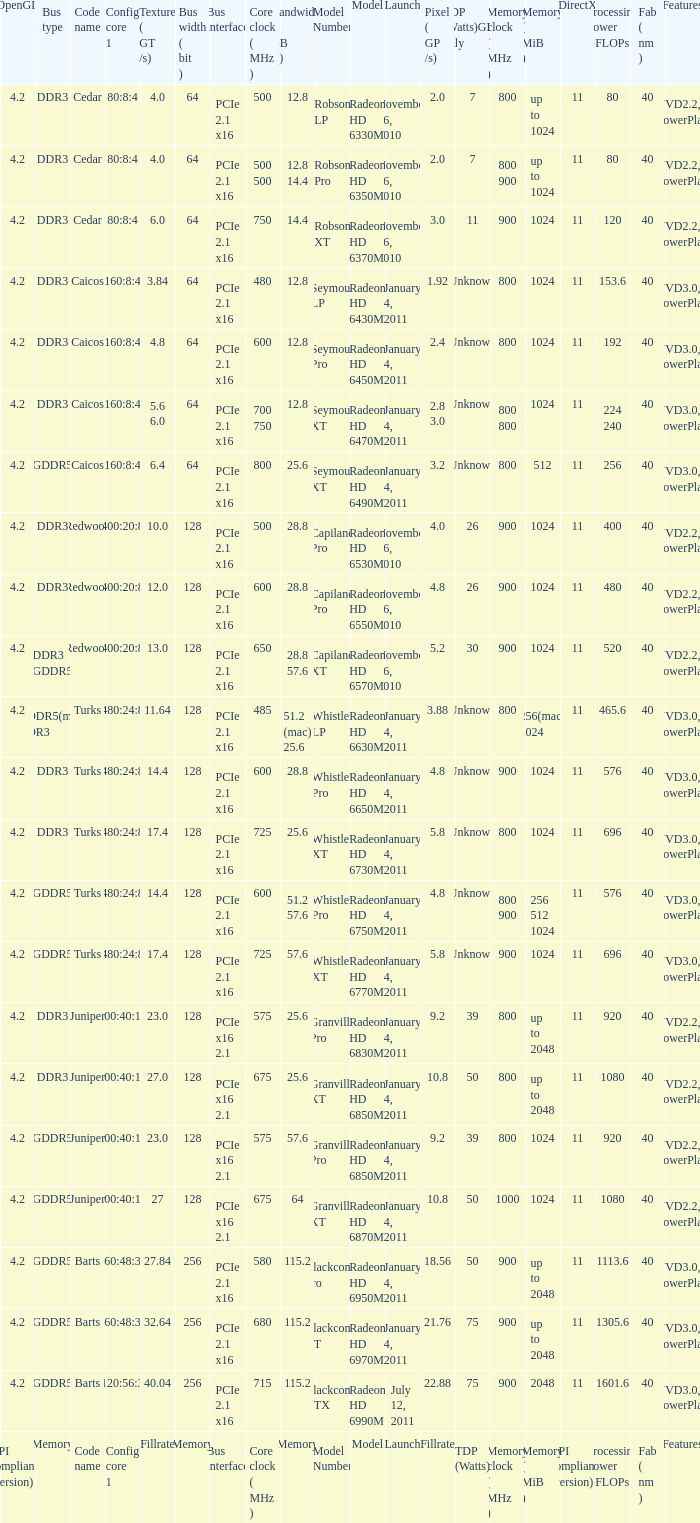Could you parse the entire table? {'header': ['OpenGL', 'Bus type', 'Code name', 'Config core 1', 'Texture ( GT /s)', 'Bus width ( bit )', 'Bus interface', 'Core clock ( MHz )', 'Bandwidth ( GB /s)', 'Model Number', 'Model', 'Launch', 'Pixel ( GP /s)', 'TDP (Watts)GPU only', 'Memory clock ( MHz )', 'Memory ( MiB )', 'DirectX', 'Processing Power GFLOPs', 'Fab ( nm )', 'Features'], 'rows': [['4.2', 'DDR3', 'Cedar', '80:8:4', '4.0', '64', 'PCIe 2.1 x16', '500', '12.8', 'Robson LP', 'Radeon HD 6330M', 'November 26, 2010', '2.0', '7', '800', 'up to 1024', '11', '80', '40', 'UVD2.2, PowerPlay'], ['4.2', 'DDR3', 'Cedar', '80:8:4', '4.0', '64', 'PCIe 2.1 x16', '500 500', '12.8 14.4', 'Robson Pro', 'Radeon HD 6350M', 'November 26, 2010', '2.0', '7', '800 900', 'up to 1024', '11', '80', '40', 'UVD2.2, PowerPlay'], ['4.2', 'DDR3', 'Cedar', '80:8:4', '6.0', '64', 'PCIe 2.1 x16', '750', '14.4', 'Robson XT', 'Radeon HD 6370M', 'November 26, 2010', '3.0', '11', '900', '1024', '11', '120', '40', 'UVD2.2, PowerPlay'], ['4.2', 'DDR3', 'Caicos', '160:8:4', '3.84', '64', 'PCIe 2.1 x16', '480', '12.8', 'Seymour LP', 'Radeon HD 6430M', 'January 4, 2011', '1.92', 'Unknown', '800', '1024', '11', '153.6', '40', 'UVD3.0, PowerPlay'], ['4.2', 'DDR3', 'Caicos', '160:8:4', '4.8', '64', 'PCIe 2.1 x16', '600', '12.8', 'Seymour Pro', 'Radeon HD 6450M', 'January 4, 2011', '2.4', 'Unknown', '800', '1024', '11', '192', '40', 'UVD3.0, PowerPlay'], ['4.2', 'DDR3', 'Caicos', '160:8:4', '5.6 6.0', '64', 'PCIe 2.1 x16', '700 750', '12.8', 'Seymour XT', 'Radeon HD 6470M', 'January 4, 2011', '2.8 3.0', 'Unknown', '800 800', '1024', '11', '224 240', '40', 'UVD3.0, PowerPlay'], ['4.2', 'GDDR5', 'Caicos', '160:8:4', '6.4', '64', 'PCIe 2.1 x16', '800', '25.6', 'Seymour XT', 'Radeon HD 6490M', 'January 4, 2011', '3.2', 'Unknown', '800', '512', '11', '256', '40', 'UVD3.0, PowerPlay'], ['4.2', 'DDR3', 'Redwood', '400:20:8', '10.0', '128', 'PCIe 2.1 x16', '500', '28.8', 'Capilano Pro', 'Radeon HD 6530M', 'November 26, 2010', '4.0', '26', '900', '1024', '11', '400', '40', 'UVD2.2, PowerPlay'], ['4.2', 'DDR3', 'Redwood', '400:20:8', '12.0', '128', 'PCIe 2.1 x16', '600', '28.8', 'Capilano Pro', 'Radeon HD 6550M', 'November 26, 2010', '4.8', '26', '900', '1024', '11', '480', '40', 'UVD2.2, PowerPlay'], ['4.2', 'DDR3 GDDR5', 'Redwood', '400:20:8', '13.0', '128', 'PCIe 2.1 x16', '650', '28.8 57.6', 'Capilano XT', 'Radeon HD 6570M', 'November 26, 2010', '5.2', '30', '900', '1024', '11', '520', '40', 'UVD2.2, PowerPlay'], ['4.2', 'GDDR5(mac) DDR3', 'Turks', '480:24:8', '11.64', '128', 'PCIe 2.1 x16', '485', '51.2 (mac) 25.6', 'Whistler LP', 'Radeon HD 6630M', 'January 4, 2011', '3.88', 'Unknown', '800', '256(mac) 1024', '11', '465.6', '40', 'UVD3.0, PowerPlay'], ['4.2', 'DDR3', 'Turks', '480:24:8', '14.4', '128', 'PCIe 2.1 x16', '600', '28.8', 'Whistler Pro', 'Radeon HD 6650M', 'January 4, 2011', '4.8', 'Unknown', '900', '1024', '11', '576', '40', 'UVD3.0, PowerPlay'], ['4.2', 'DDR3', 'Turks', '480:24:8', '17.4', '128', 'PCIe 2.1 x16', '725', '25.6', 'Whistler XT', 'Radeon HD 6730M', 'January 4, 2011', '5.8', 'Unknown', '800', '1024', '11', '696', '40', 'UVD3.0, PowerPlay'], ['4.2', 'GDDR5', 'Turks', '480:24:8', '14.4', '128', 'PCIe 2.1 x16', '600', '51.2 57.6', 'Whistler Pro', 'Radeon HD 6750M', 'January 4, 2011', '4.8', 'Unknown', '800 900', '256 512 1024', '11', '576', '40', 'UVD3.0, PowerPlay'], ['4.2', 'GDDR5', 'Turks', '480:24:8', '17.4', '128', 'PCIe 2.1 x16', '725', '57.6', 'Whistler XT', 'Radeon HD 6770M', 'January 4, 2011', '5.8', 'Unknown', '900', '1024', '11', '696', '40', 'UVD3.0, PowerPlay'], ['4.2', 'DDR3', 'Juniper', '800:40:16', '23.0', '128', 'PCIe x16 2.1', '575', '25.6', 'Granville Pro', 'Radeon HD 6830M', 'January 4, 2011', '9.2', '39', '800', 'up to 2048', '11', '920', '40', 'UVD2.2, PowerPlay'], ['4.2', 'DDR3', 'Juniper', '800:40:16', '27.0', '128', 'PCIe x16 2.1', '675', '25.6', 'Granville XT', 'Radeon HD 6850M', 'January 4, 2011', '10.8', '50', '800', 'up to 2048', '11', '1080', '40', 'UVD2.2, PowerPlay'], ['4.2', 'GDDR5', 'Juniper', '800:40:16', '23.0', '128', 'PCIe x16 2.1', '575', '57.6', 'Granville Pro', 'Radeon HD 6850M', 'January 4, 2011', '9.2', '39', '800', '1024', '11', '920', '40', 'UVD2.2, PowerPlay'], ['4.2', 'GDDR5', 'Juniper', '800:40:16', '27', '128', 'PCIe x16 2.1', '675', '64', 'Granville XT', 'Radeon HD 6870M', 'January 4, 2011', '10.8', '50', '1000', '1024', '11', '1080', '40', 'UVD2.2, PowerPlay'], ['4.2', 'GDDR5', 'Barts', '960:48:32', '27.84', '256', 'PCIe 2.1 x16', '580', '115.2', 'Blackcomb Pro', 'Radeon HD 6950M', 'January 4, 2011', '18.56', '50', '900', 'up to 2048', '11', '1113.6', '40', 'UVD3.0, PowerPlay'], ['4.2', 'GDDR5', 'Barts', '960:48:32', '32.64', '256', 'PCIe 2.1 x16', '680', '115.2', 'Blackcomb XT', 'Radeon HD 6970M', 'January 4, 2011', '21.76', '75', '900', 'up to 2048', '11', '1305.6', '40', 'UVD3.0, PowerPlay'], ['4.2', 'GDDR5', 'Barts', '1120:56:32', '40.04', '256', 'PCIe 2.1 x16', '715', '115.2', 'Blackcomb XTX', 'Radeon HD 6990M', 'July 12, 2011', '22.88', '75', '900', '2048', '11', '1601.6', '40', 'UVD3.0, PowerPlay'], ['API compliance (version)', 'Memory', 'Code name', 'Config core 1', 'Fillrate', 'Memory', 'Bus interface', 'Core clock ( MHz )', 'Memory', 'Model Number', 'Model', 'Launch', 'Fillrate', 'TDP (Watts)', 'Memory clock ( MHz )', 'Memory ( MiB )', 'API compliance (version)', 'Processing Power GFLOPs', 'Fab ( nm )', 'Features']]} How many values for fab(nm) if the model number is Whistler LP? 1.0. 